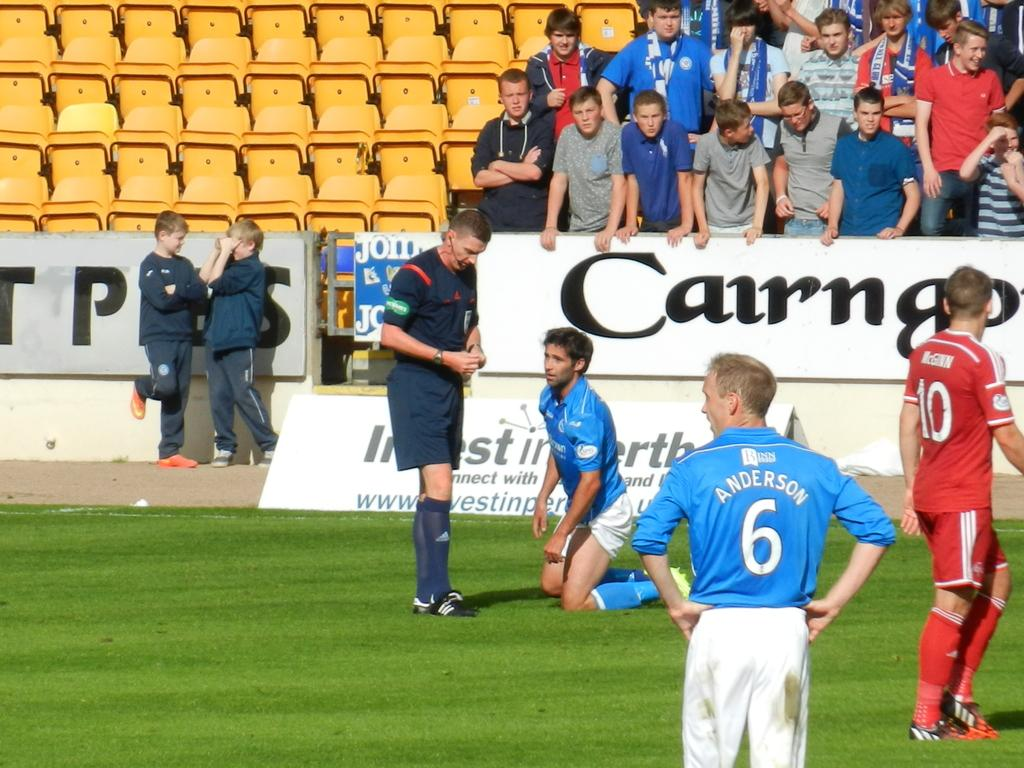<image>
Describe the image concisely. A soccer player is on his knees talking to the ref with a crowd behind them and Anderson number 6 looking on. 